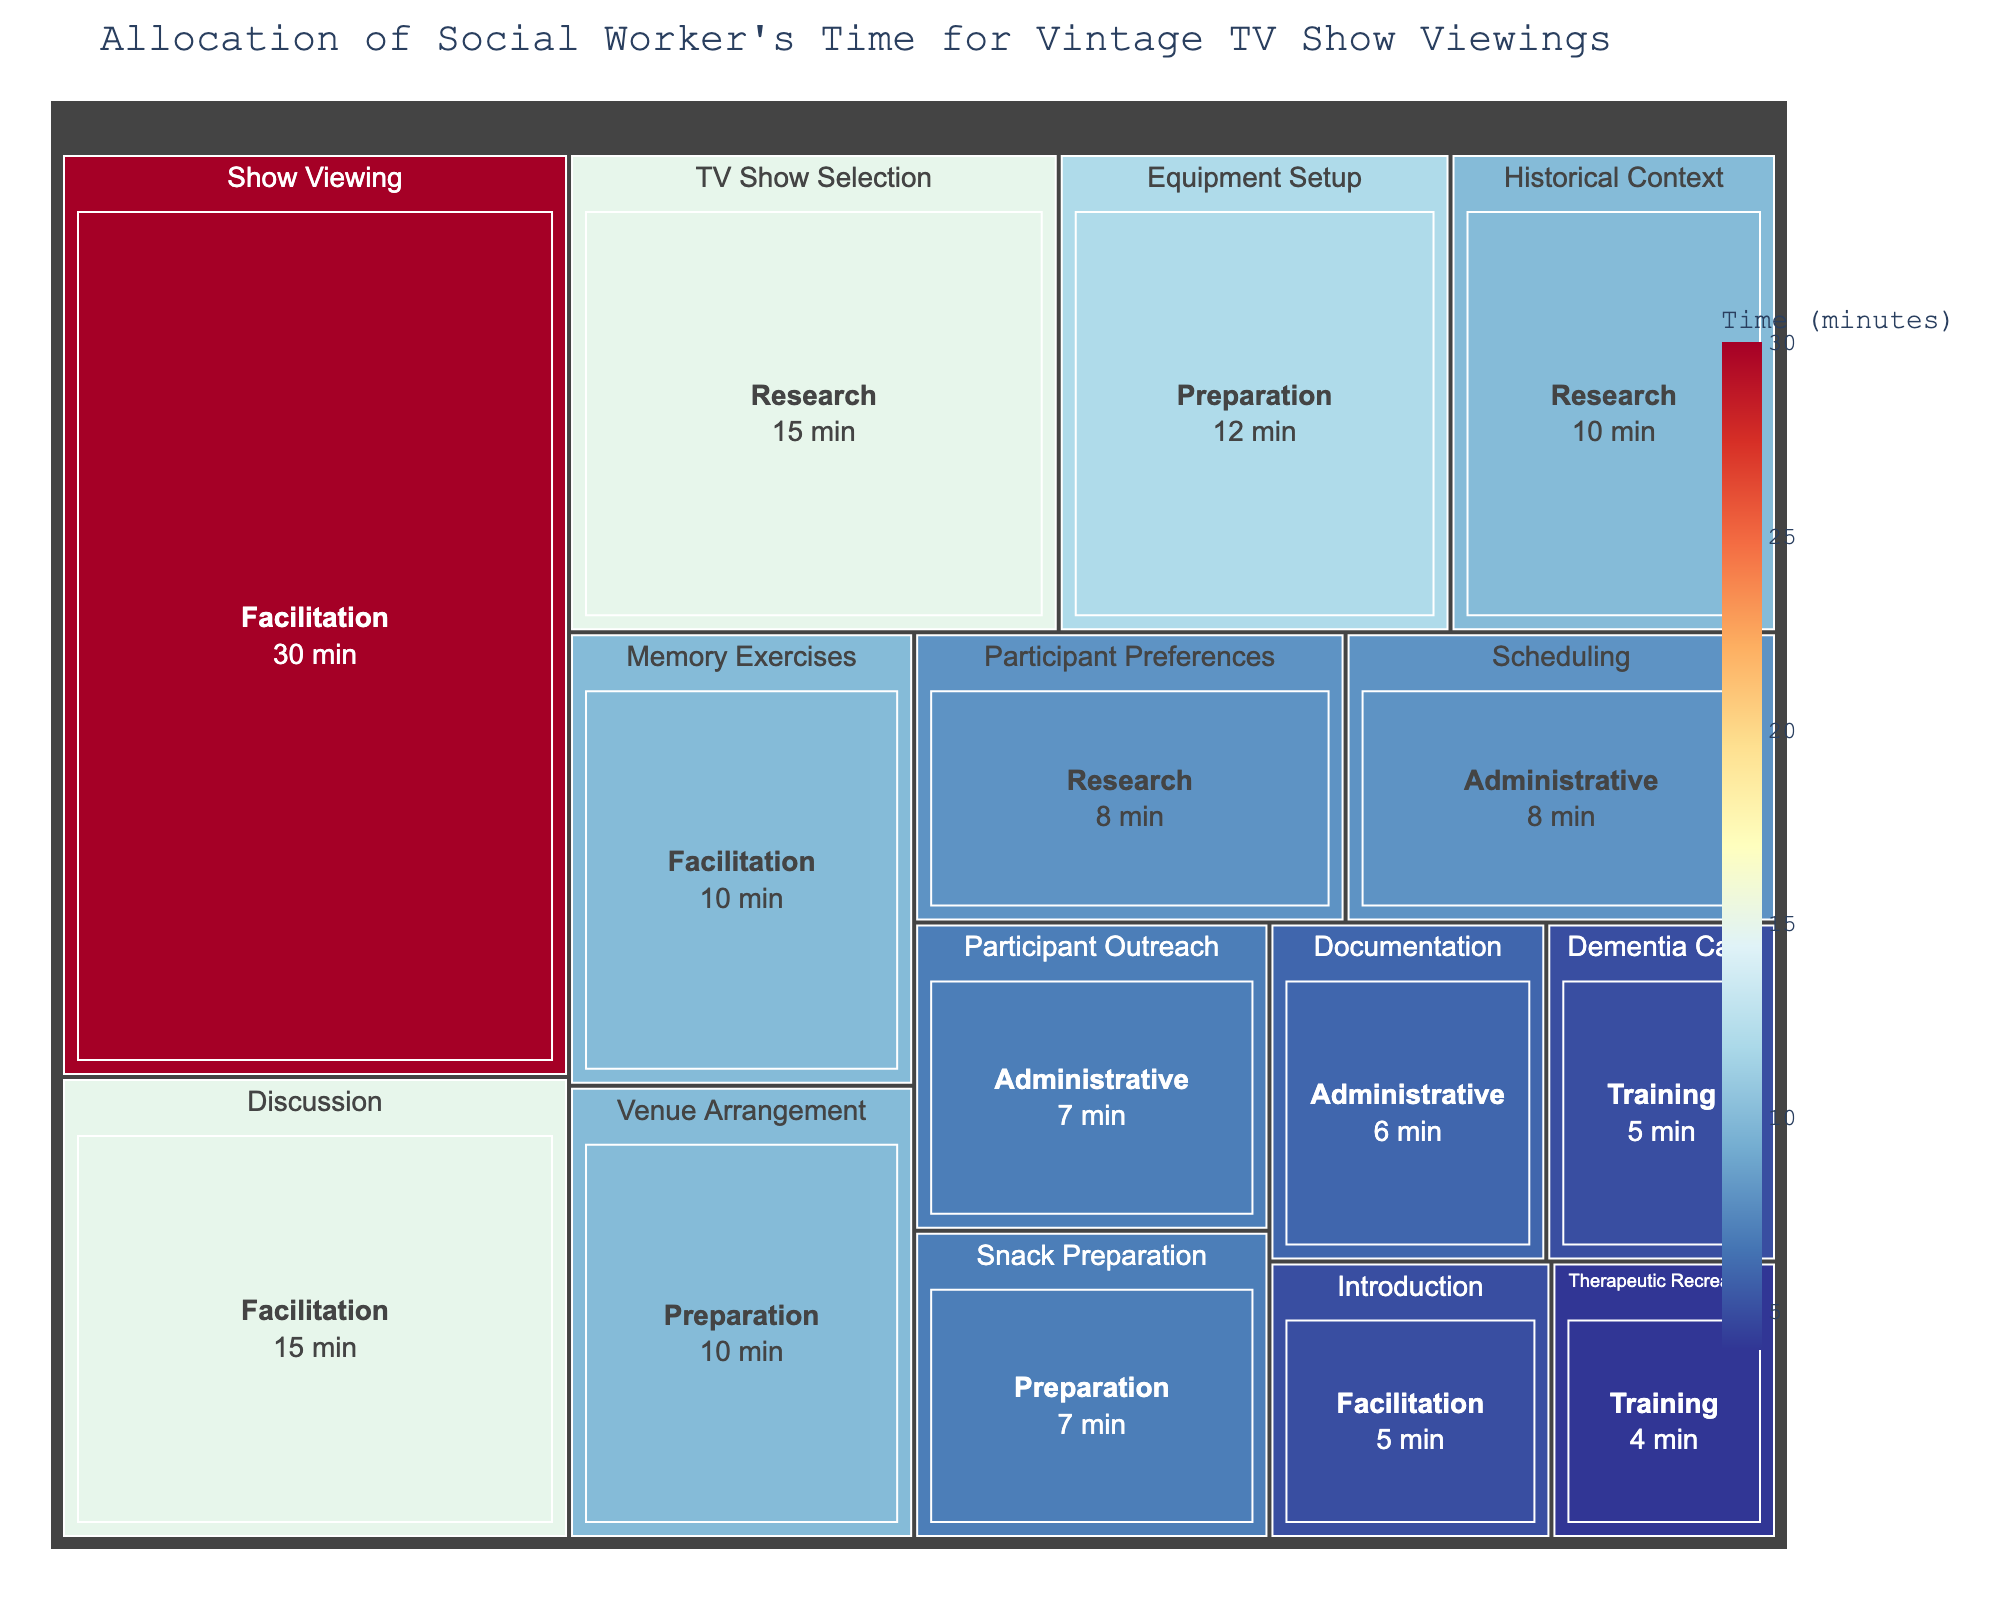What is the overall title of the treemap? The overall title is usually located at the top of the figure. In this case, it is specified in the code when creating the treemap.
Answer: Allocation of Social Worker's Time for Vintage TV Show Viewings Which activity takes the longest time? Look at the segments in the treemap. The activity with the largest segment will correspond to the one that takes the most time.
Answer: Show Viewing How much total time is spent on Research activities? Sum the individual time values for activities under the Research category (TV Show Selection, Historical Context, Participant Preferences). The times are 15, 10, and 8 minutes respectively. 15 + 10 + 8 = 33 minutes.
Answer: 33 minutes Which category has the most diverse set of activities? Identify the category with the largest number of distinct sub-segments. Each unique sub-segment corresponds to a different activity.
Answer: Facilitation Is more time spent on Preparation or Administrative activities? Add up the times for activities under each category, then compare. Preparation: Equipment Setup (12) + Venue Arrangement (10) + Snack Preparation (7) = 29 minutes. Administrative: Scheduling (8) + Participant Outreach (7) + Documentation (6) = 21 minutes. Since 29 > 21, more time is spent on Preparation.
Answer: Preparation What is the ratio of time spent on Show Viewing to Discussion during Facilitation? The time for Show Viewing is 30 minutes and for Discussion is 15 minutes. The ratio is 30:15, which simplifies to 2:1.
Answer: 2:1 How much less time is spent on Snack Preparation compared to Equipment Setup? Subtract the time for Snack Preparation from the time for Equipment Setup. Equipment Setup is 12 minutes, and Snack Preparation is 7 minutes. 12 - 7 = 5 minutes.
Answer: 5 minutes What is the combined time spent on both Participant Outreach and Documentation? Add the times for both Participant Outreach (7 minutes) and Documentation (6 minutes). 7 + 6 = 13 minutes.
Answer: 13 minutes What activity within the Research category takes the least time? Identify the smallest segment under the Research category in the treemap. Participant Preferences, at 8 minutes, is the smallest.
Answer: Participant Preferences Which category has the smallest total time allocation, and what is its total time? Sum up the times for each category and identify the smallest. Training (Dementia Care: 5, Therapeutic Recreation: 4) totals 9 minutes, which is the smallest.
Answer: Training, 9 minutes 